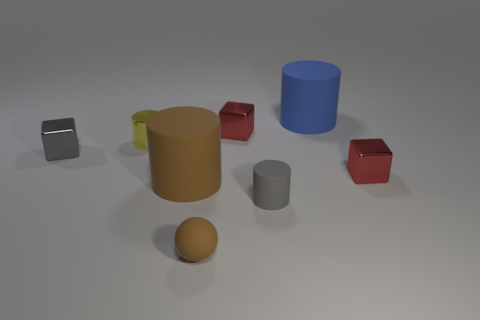Do the matte ball that is to the right of the brown cylinder and the big matte object in front of the big blue thing have the same color?
Your answer should be very brief. Yes. There is a red thing behind the small block right of the blue rubber object; how big is it?
Your answer should be compact. Small. How many other objects are the same size as the metal cylinder?
Your response must be concise. 5. There is a tiny yellow metallic cylinder; what number of things are left of it?
Ensure brevity in your answer.  1. How big is the gray shiny object?
Your response must be concise. Small. Do the small gray object left of the gray cylinder and the small red object that is in front of the gray metallic thing have the same material?
Provide a short and direct response. Yes. Is there a thing of the same color as the rubber sphere?
Ensure brevity in your answer.  Yes. There is another object that is the same size as the blue matte object; what color is it?
Keep it short and to the point. Brown. There is a large thing that is left of the blue cylinder; does it have the same color as the tiny matte sphere?
Your answer should be compact. Yes. Are there any small yellow cylinders that have the same material as the blue object?
Provide a succinct answer. No. 